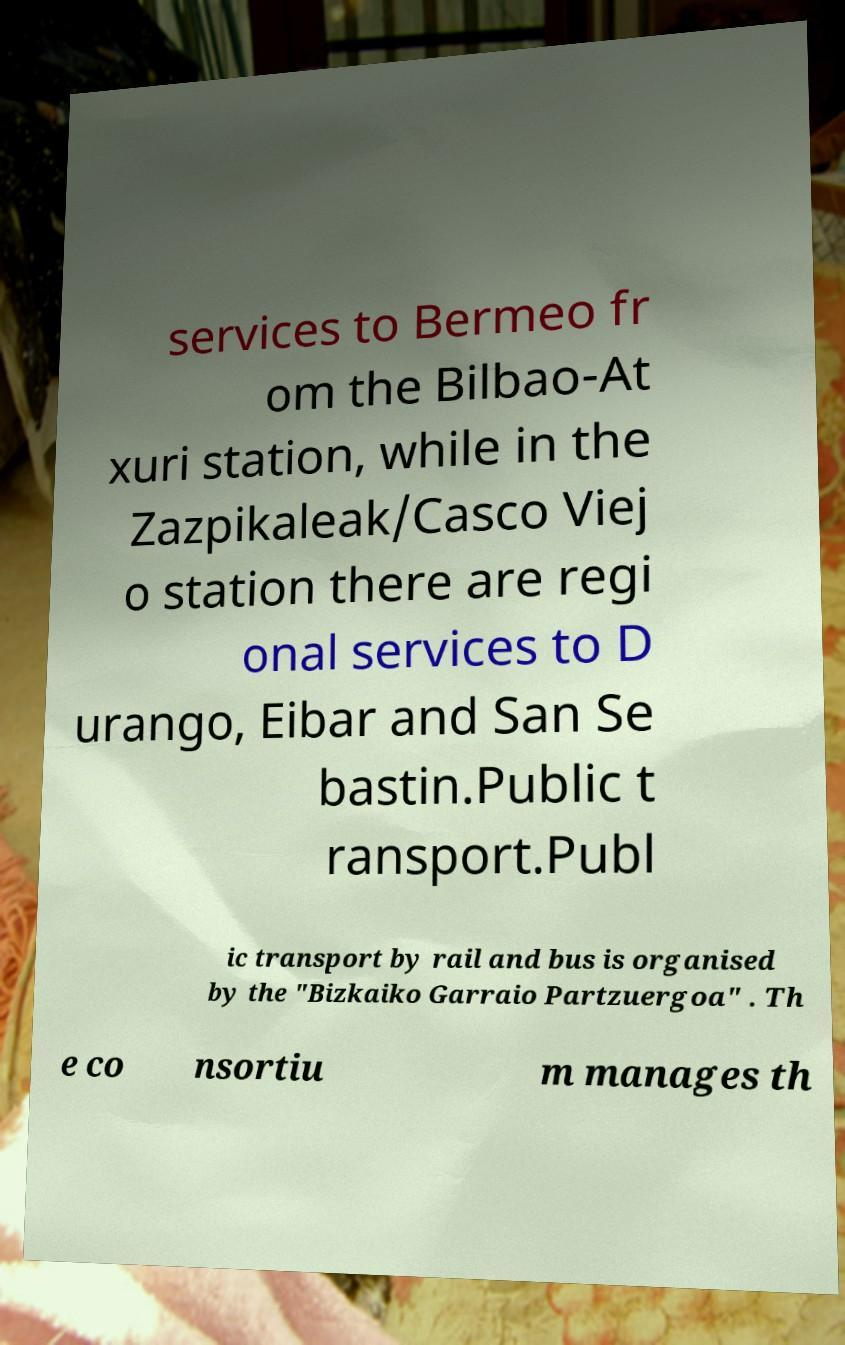For documentation purposes, I need the text within this image transcribed. Could you provide that? services to Bermeo fr om the Bilbao-At xuri station, while in the Zazpikaleak/Casco Viej o station there are regi onal services to D urango, Eibar and San Se bastin.Public t ransport.Publ ic transport by rail and bus is organised by the "Bizkaiko Garraio Partzuergoa" . Th e co nsortiu m manages th 